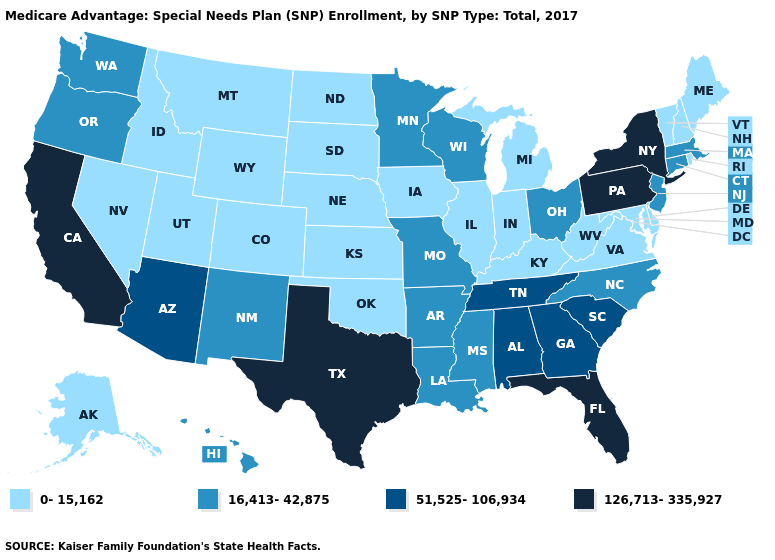Name the states that have a value in the range 51,525-106,934?
Quick response, please. Alabama, Arizona, Georgia, South Carolina, Tennessee. Among the states that border Montana , which have the lowest value?
Concise answer only. Idaho, North Dakota, South Dakota, Wyoming. What is the value of Wyoming?
Short answer required. 0-15,162. Among the states that border Kentucky , which have the lowest value?
Answer briefly. Illinois, Indiana, Virginia, West Virginia. What is the value of Maine?
Answer briefly. 0-15,162. Does Massachusetts have a lower value than Michigan?
Keep it brief. No. Name the states that have a value in the range 51,525-106,934?
Keep it brief. Alabama, Arizona, Georgia, South Carolina, Tennessee. Does Louisiana have the lowest value in the USA?
Be succinct. No. What is the value of Ohio?
Give a very brief answer. 16,413-42,875. What is the value of South Dakota?
Be succinct. 0-15,162. Name the states that have a value in the range 51,525-106,934?
Short answer required. Alabama, Arizona, Georgia, South Carolina, Tennessee. What is the value of Texas?
Concise answer only. 126,713-335,927. What is the value of Texas?
Short answer required. 126,713-335,927. Does Texas have the highest value in the USA?
Write a very short answer. Yes. Name the states that have a value in the range 16,413-42,875?
Keep it brief. Arkansas, Connecticut, Hawaii, Louisiana, Massachusetts, Minnesota, Missouri, Mississippi, North Carolina, New Jersey, New Mexico, Ohio, Oregon, Washington, Wisconsin. 